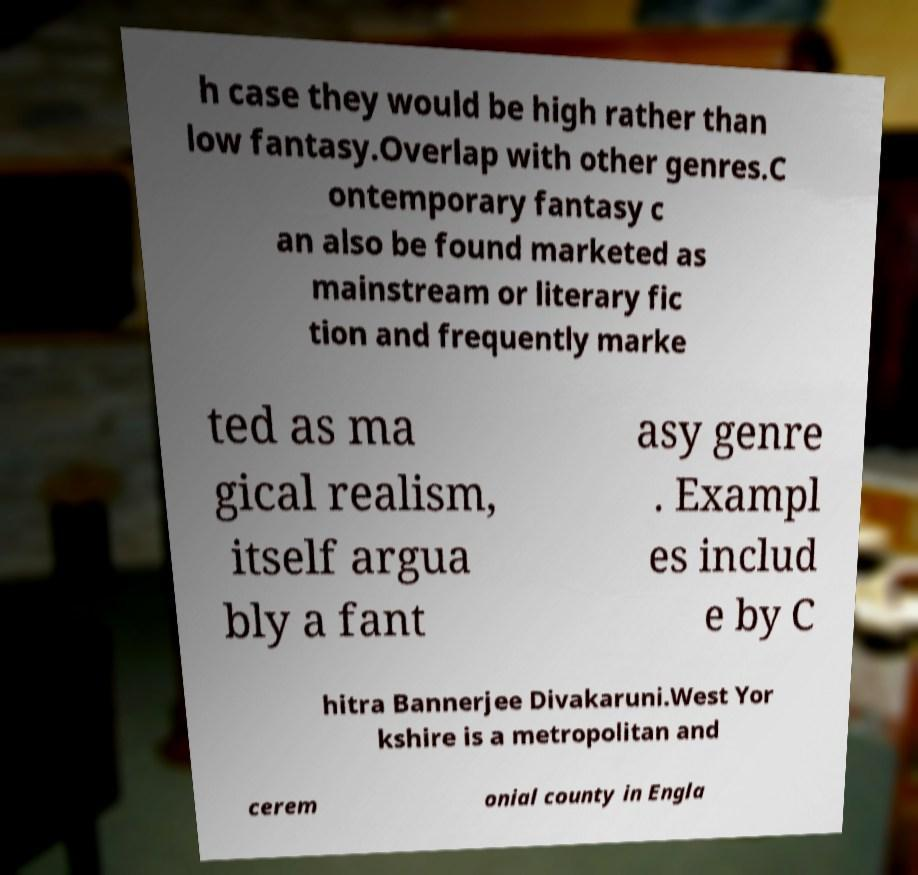Please identify and transcribe the text found in this image. h case they would be high rather than low fantasy.Overlap with other genres.C ontemporary fantasy c an also be found marketed as mainstream or literary fic tion and frequently marke ted as ma gical realism, itself argua bly a fant asy genre . Exampl es includ e by C hitra Bannerjee Divakaruni.West Yor kshire is a metropolitan and cerem onial county in Engla 